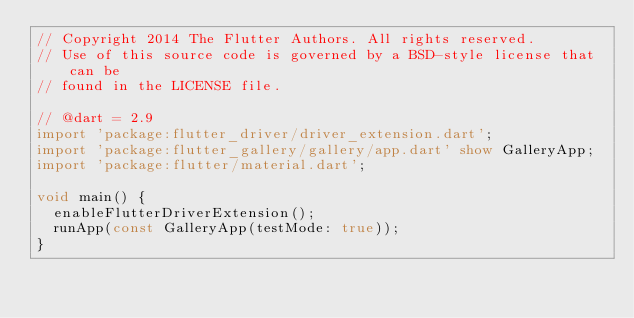<code> <loc_0><loc_0><loc_500><loc_500><_Dart_>// Copyright 2014 The Flutter Authors. All rights reserved.
// Use of this source code is governed by a BSD-style license that can be
// found in the LICENSE file.

// @dart = 2.9
import 'package:flutter_driver/driver_extension.dart';
import 'package:flutter_gallery/gallery/app.dart' show GalleryApp;
import 'package:flutter/material.dart';

void main() {
  enableFlutterDriverExtension();
  runApp(const GalleryApp(testMode: true));
}
</code> 